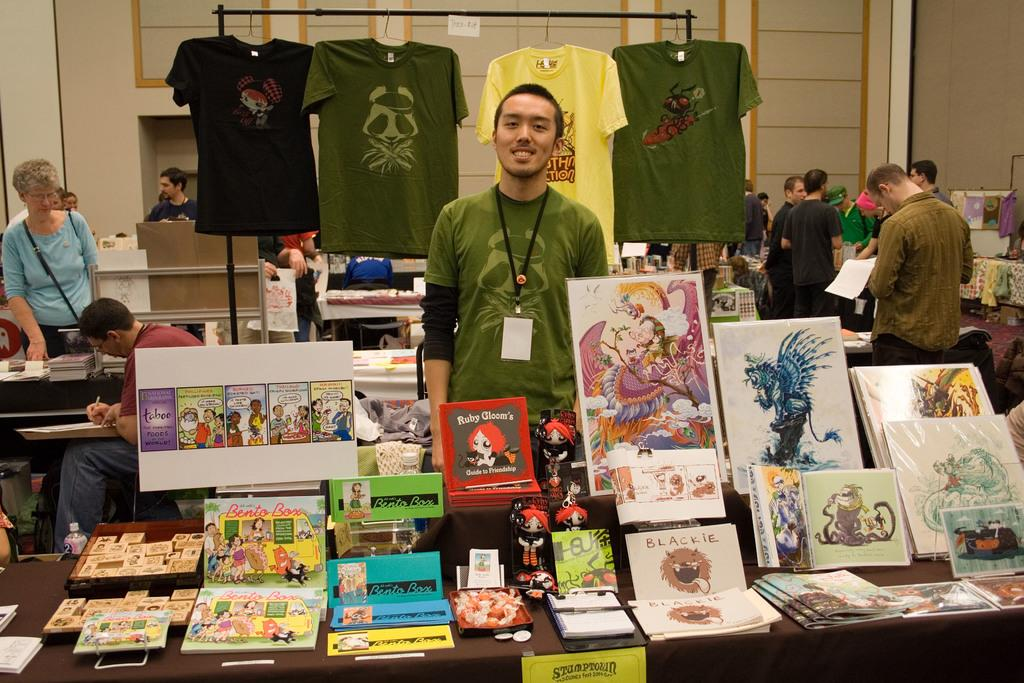<image>
Give a short and clear explanation of the subsequent image. A man stands at an art display with various merchandise including Ruby Gloom's Guide to Friendship 